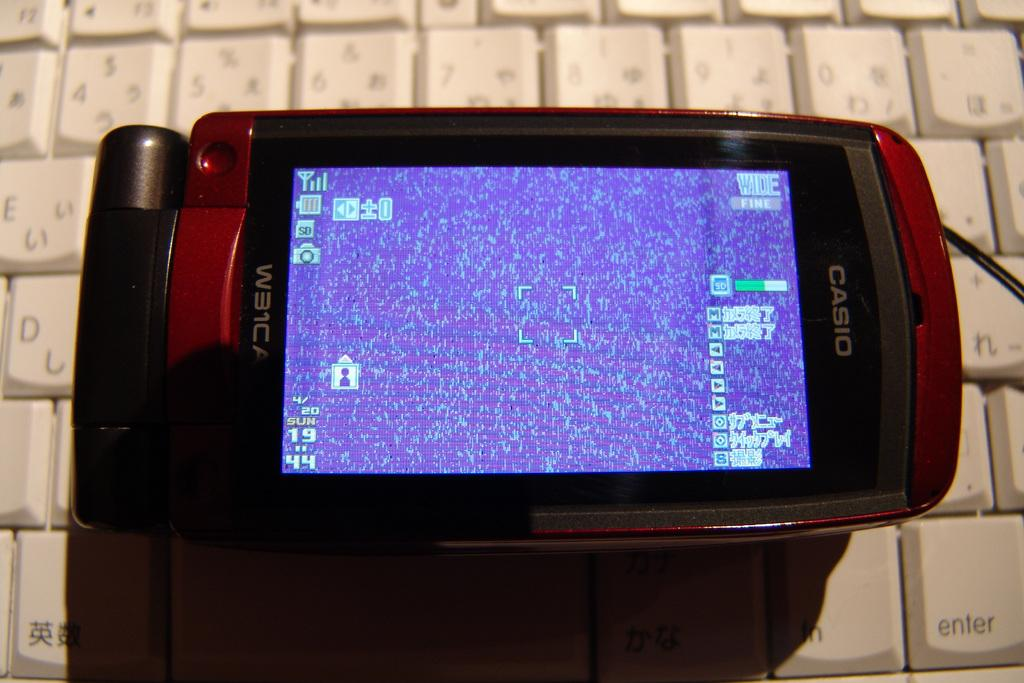<image>
Give a short and clear explanation of the subsequent image. A red Casio cell phone sits atop a computer keyboard. 